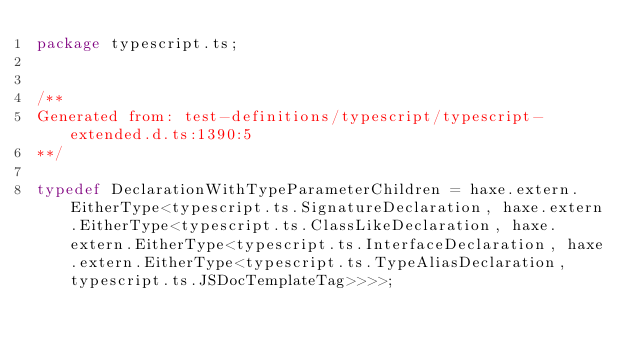<code> <loc_0><loc_0><loc_500><loc_500><_Haxe_>package typescript.ts;


/**
Generated from: test-definitions/typescript/typescript-extended.d.ts:1390:5
**/

typedef DeclarationWithTypeParameterChildren = haxe.extern.EitherType<typescript.ts.SignatureDeclaration, haxe.extern.EitherType<typescript.ts.ClassLikeDeclaration, haxe.extern.EitherType<typescript.ts.InterfaceDeclaration, haxe.extern.EitherType<typescript.ts.TypeAliasDeclaration, typescript.ts.JSDocTemplateTag>>>>;



</code> 